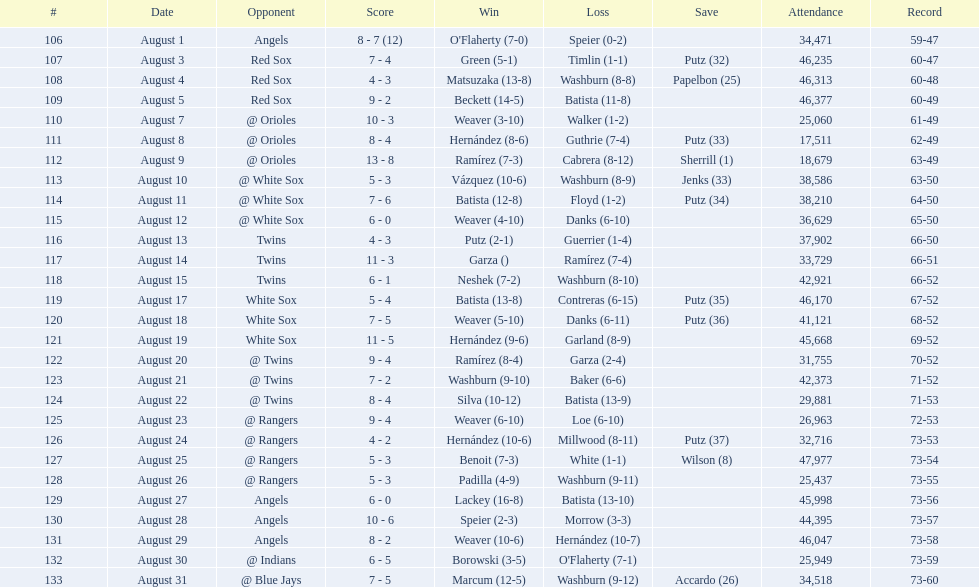Write the full table. {'header': ['#', 'Date', 'Opponent', 'Score', 'Win', 'Loss', 'Save', 'Attendance', 'Record'], 'rows': [['106', 'August 1', 'Angels', '8 - 7 (12)', "O'Flaherty (7-0)", 'Speier (0-2)', '', '34,471', '59-47'], ['107', 'August 3', 'Red Sox', '7 - 4', 'Green (5-1)', 'Timlin (1-1)', 'Putz (32)', '46,235', '60-47'], ['108', 'August 4', 'Red Sox', '4 - 3', 'Matsuzaka (13-8)', 'Washburn (8-8)', 'Papelbon (25)', '46,313', '60-48'], ['109', 'August 5', 'Red Sox', '9 - 2', 'Beckett (14-5)', 'Batista (11-8)', '', '46,377', '60-49'], ['110', 'August 7', '@ Orioles', '10 - 3', 'Weaver (3-10)', 'Walker (1-2)', '', '25,060', '61-49'], ['111', 'August 8', '@ Orioles', '8 - 4', 'Hernández (8-6)', 'Guthrie (7-4)', 'Putz (33)', '17,511', '62-49'], ['112', 'August 9', '@ Orioles', '13 - 8', 'Ramírez (7-3)', 'Cabrera (8-12)', 'Sherrill (1)', '18,679', '63-49'], ['113', 'August 10', '@ White Sox', '5 - 3', 'Vázquez (10-6)', 'Washburn (8-9)', 'Jenks (33)', '38,586', '63-50'], ['114', 'August 11', '@ White Sox', '7 - 6', 'Batista (12-8)', 'Floyd (1-2)', 'Putz (34)', '38,210', '64-50'], ['115', 'August 12', '@ White Sox', '6 - 0', 'Weaver (4-10)', 'Danks (6-10)', '', '36,629', '65-50'], ['116', 'August 13', 'Twins', '4 - 3', 'Putz (2-1)', 'Guerrier (1-4)', '', '37,902', '66-50'], ['117', 'August 14', 'Twins', '11 - 3', 'Garza ()', 'Ramírez (7-4)', '', '33,729', '66-51'], ['118', 'August 15', 'Twins', '6 - 1', 'Neshek (7-2)', 'Washburn (8-10)', '', '42,921', '66-52'], ['119', 'August 17', 'White Sox', '5 - 4', 'Batista (13-8)', 'Contreras (6-15)', 'Putz (35)', '46,170', '67-52'], ['120', 'August 18', 'White Sox', '7 - 5', 'Weaver (5-10)', 'Danks (6-11)', 'Putz (36)', '41,121', '68-52'], ['121', 'August 19', 'White Sox', '11 - 5', 'Hernández (9-6)', 'Garland (8-9)', '', '45,668', '69-52'], ['122', 'August 20', '@ Twins', '9 - 4', 'Ramírez (8-4)', 'Garza (2-4)', '', '31,755', '70-52'], ['123', 'August 21', '@ Twins', '7 - 2', 'Washburn (9-10)', 'Baker (6-6)', '', '42,373', '71-52'], ['124', 'August 22', '@ Twins', '8 - 4', 'Silva (10-12)', 'Batista (13-9)', '', '29,881', '71-53'], ['125', 'August 23', '@ Rangers', '9 - 4', 'Weaver (6-10)', 'Loe (6-10)', '', '26,963', '72-53'], ['126', 'August 24', '@ Rangers', '4 - 2', 'Hernández (10-6)', 'Millwood (8-11)', 'Putz (37)', '32,716', '73-53'], ['127', 'August 25', '@ Rangers', '5 - 3', 'Benoit (7-3)', 'White (1-1)', 'Wilson (8)', '47,977', '73-54'], ['128', 'August 26', '@ Rangers', '5 - 3', 'Padilla (4-9)', 'Washburn (9-11)', '', '25,437', '73-55'], ['129', 'August 27', 'Angels', '6 - 0', 'Lackey (16-8)', 'Batista (13-10)', '', '45,998', '73-56'], ['130', 'August 28', 'Angels', '10 - 6', 'Speier (2-3)', 'Morrow (3-3)', '', '44,395', '73-57'], ['131', 'August 29', 'Angels', '8 - 2', 'Weaver (10-6)', 'Hernández (10-7)', '', '46,047', '73-58'], ['132', 'August 30', '@ Indians', '6 - 5', 'Borowski (3-5)', "O'Flaherty (7-1)", '', '25,949', '73-59'], ['133', 'August 31', '@ Blue Jays', '7 - 5', 'Marcum (12-5)', 'Washburn (9-12)', 'Accardo (26)', '34,518', '73-60']]} Which games had an attendance of over 30,000 people? 21. 